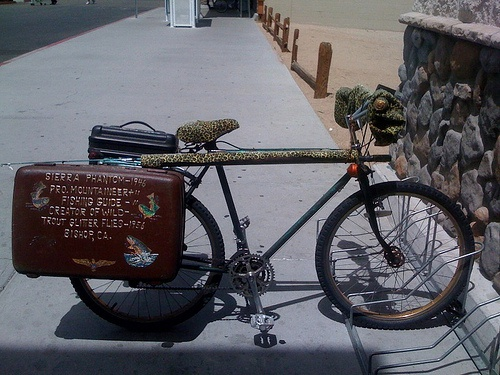Describe the objects in this image and their specific colors. I can see bicycle in black, darkgray, and gray tones, suitcase in black, gray, maroon, and darkgray tones, and suitcase in black, gray, and darkgray tones in this image. 